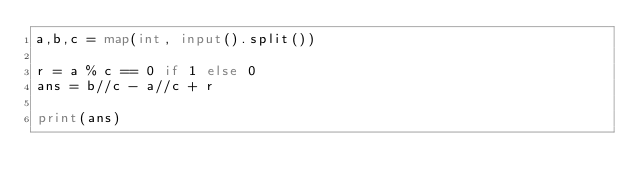<code> <loc_0><loc_0><loc_500><loc_500><_Python_>a,b,c = map(int, input().split())

r = a % c == 0 if 1 else 0
ans = b//c - a//c + r

print(ans)
</code> 